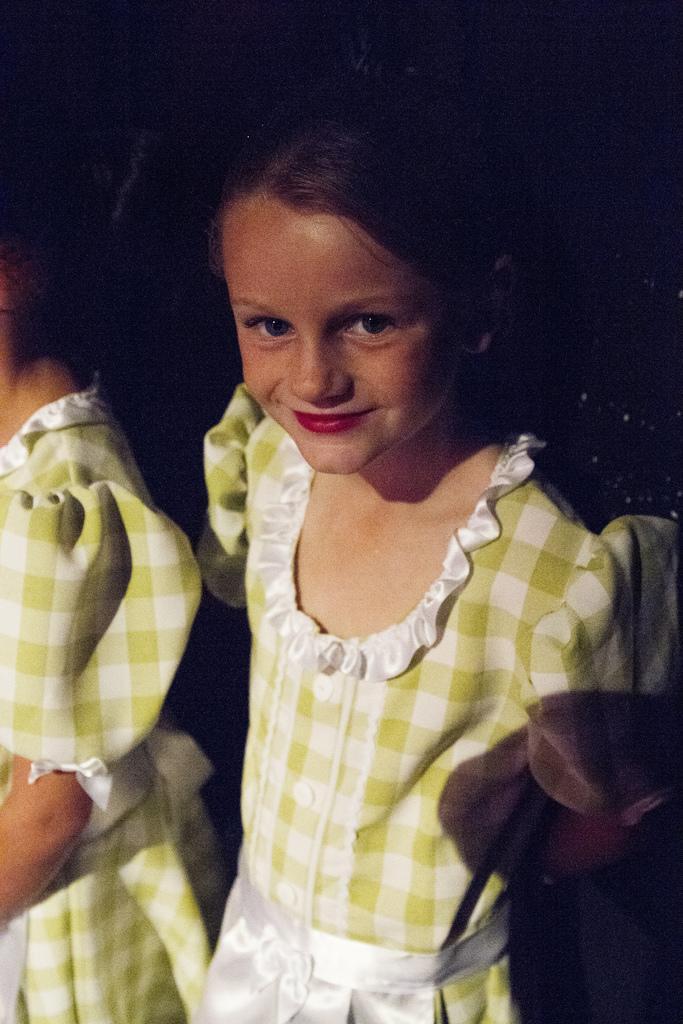How would you summarize this image in a sentence or two? In the image we can see there is a girl standing and she is wearing frock. Beside her there is another girl standing. 